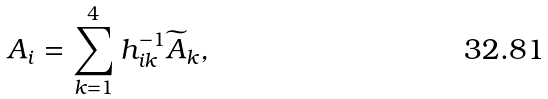<formula> <loc_0><loc_0><loc_500><loc_500>A _ { i } = \sum _ { k = 1 } ^ { 4 } h _ { i k } ^ { - 1 } \widetilde { A } _ { k } ,</formula> 